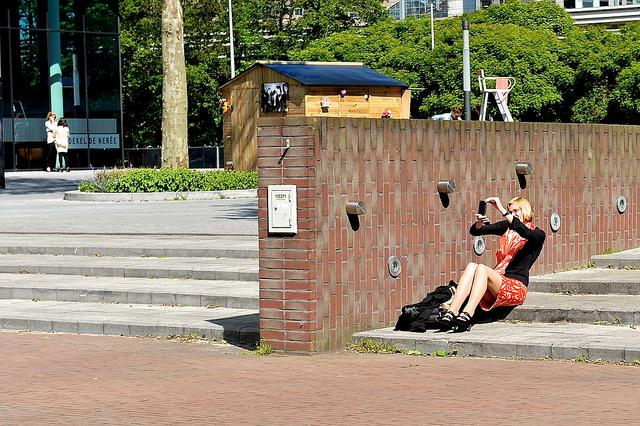Why does the woman have her arms out? Please explain your reasoning. take picture. The woman sitting on the steps has her arms out to take a picture of herself with her cameraphone. 